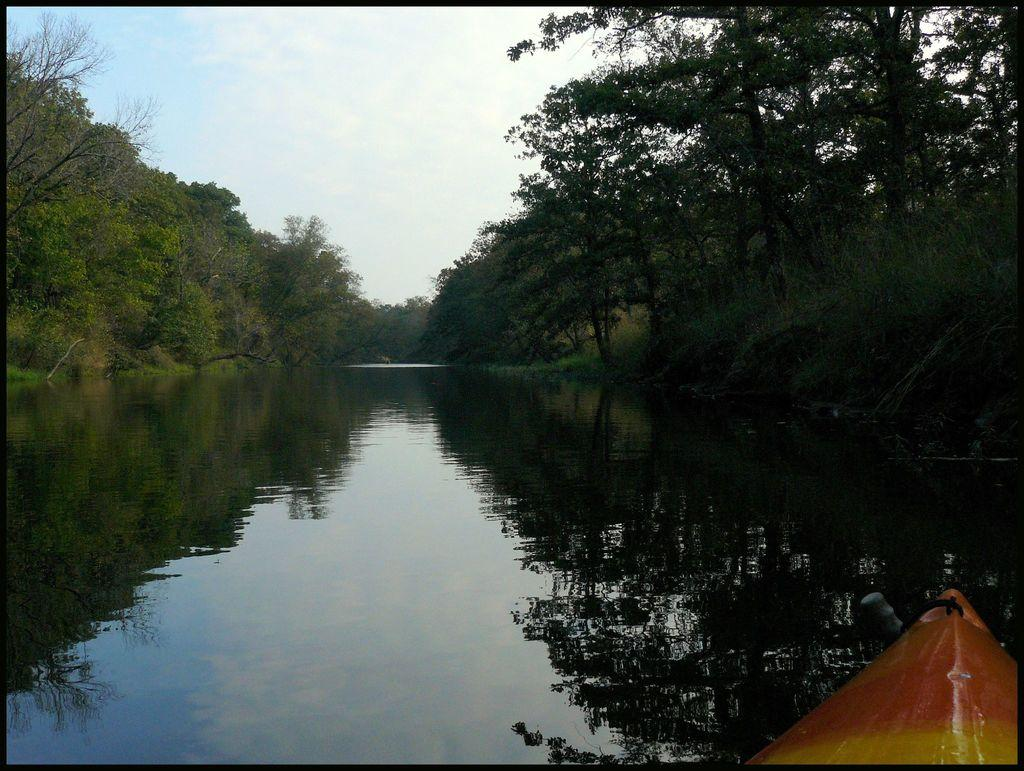What can be seen in the background of the image? The sky is visible in the background of the image. What type of natural elements are present in the image? There are trees and water in the image. Can you describe the object located in the bottom right corner of the image? Unfortunately, the provided facts do not give enough information to describe the object in the bottom right corner of the image. What time of day is depicted in the image based on the position of the hour in the sky? There is no hour present in the image, as the provided facts only mention the sky being visible in the background. Can you describe the contents of the drawer in the image? There is no drawer present in the image, as the provided facts only mention the sky, trees, water, and an object in the bottom right corner. 